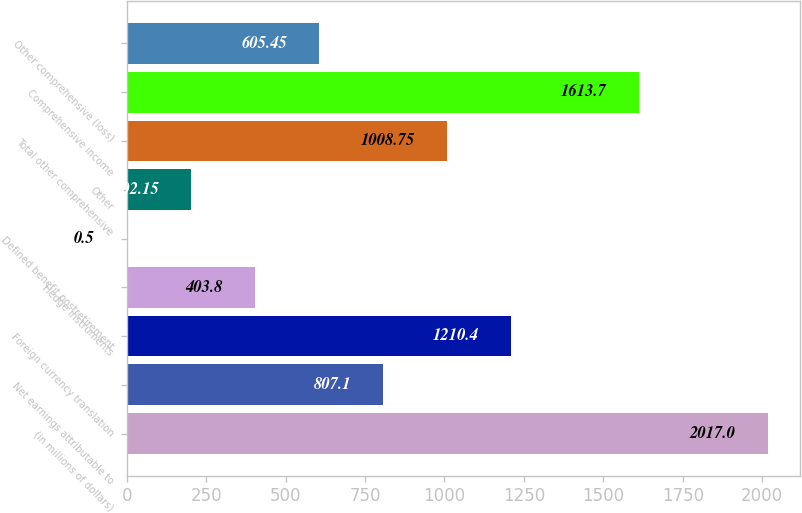Convert chart to OTSL. <chart><loc_0><loc_0><loc_500><loc_500><bar_chart><fcel>(in millions of dollars)<fcel>Net earnings attributable to<fcel>Foreign currency translation<fcel>Hedge instruments<fcel>Defined benefit postretirement<fcel>Other<fcel>Total other comprehensive<fcel>Comprehensive income<fcel>Other comprehensive (loss)<nl><fcel>2017<fcel>807.1<fcel>1210.4<fcel>403.8<fcel>0.5<fcel>202.15<fcel>1008.75<fcel>1613.7<fcel>605.45<nl></chart> 